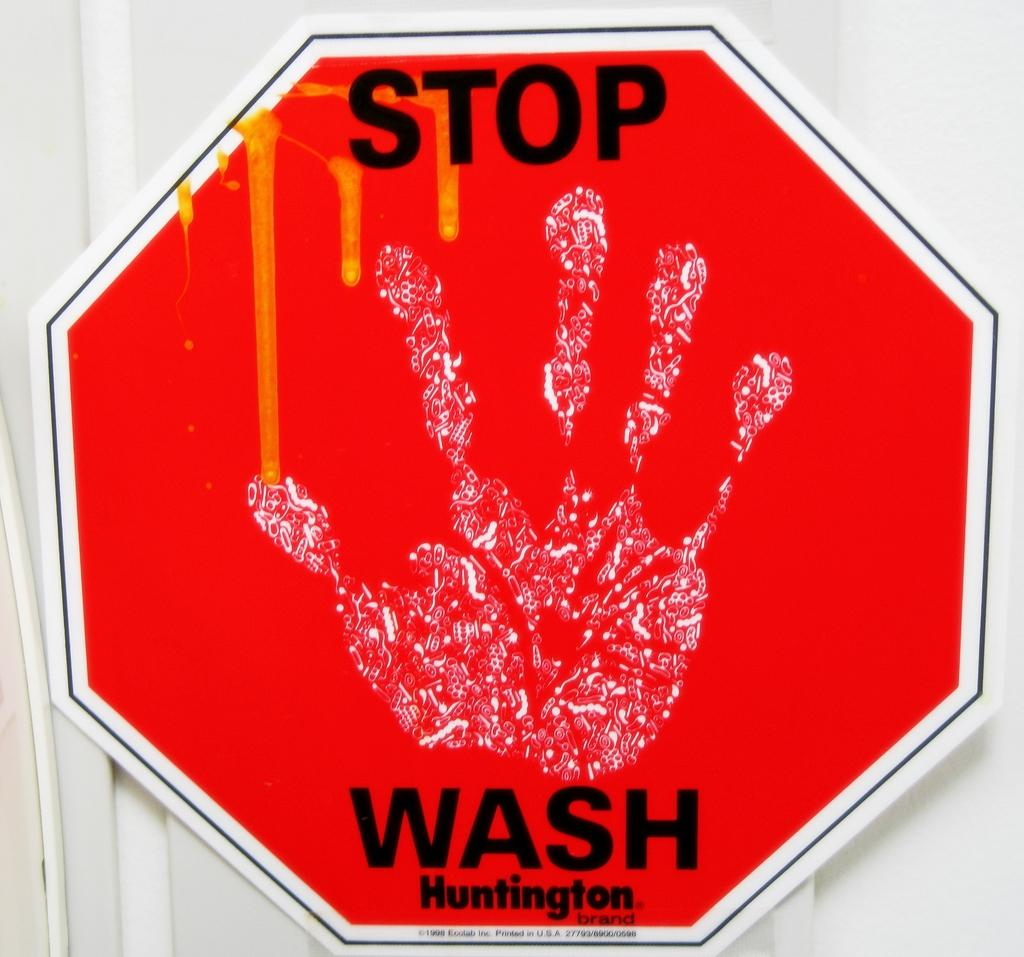Provide a one-sentence caption for the provided image. The red stop sign says STOP WASH Huntington. 